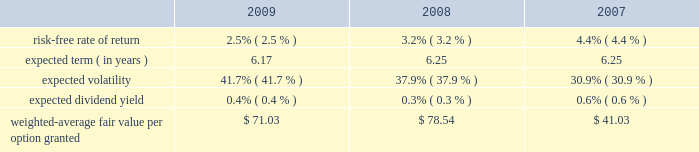Mastercard incorporated notes to consolidated financial statements 2014 ( continued ) ( in thousands , except percent and per share data ) upon termination of employment , excluding retirement , all of a participant 2019s unvested awards are forfeited .
However , when a participant terminates employment due to retirement , the participant generally retains all of their awards without providing additional service to the company .
Eligible retirement is dependent upon age and years of service , as follows : age 55 with ten years of service , age 60 with five years of service and age 65 with two years of service .
Compensation expense is recognized over the shorter of the vesting periods stated in the ltip , or the date the individual becomes eligible to retire .
There are 11550 shares of class a common stock reserved for equity awards under the ltip .
Although the ltip permits the issuance of shares of class b common stock , no such shares have been reserved for issuance .
Shares issued as a result of option exercises and the conversions of rsus are expected to be funded with the issuance of new shares of class a common stock .
Stock options the fair value of each option is estimated on the date of grant using a black-scholes option pricing model .
The table presents the weighted-average assumptions used in the valuation and the resulting weighted- average fair value per option granted for the years ended december 31: .
The risk-free rate of return was based on the u.s .
Treasury yield curve in effect on the date of grant .
The company utilizes the simplified method for calculating the expected term of the option based on the vesting terms and the contractual life of the option .
The expected volatility for options granted during 2009 was based on the average of the implied volatility of mastercard and a blend of the historical volatility of mastercard and the historical volatility of a group of companies that management believes is generally comparable to mastercard .
The expected volatility for options granted during 2008 was based on the average of the implied volatility of mastercard and the historical volatility of a group of companies that management believes is generally comparable to mastercard .
As the company did not have sufficient publicly traded stock data historically , the expected volatility for options granted during 2007 was primarily based on the average of the historical and implied volatility of a group of companies that management believed was generally comparable to mastercard .
The expected dividend yields were based on the company 2019s expected annual dividend rate on the date of grant. .
What is the average expected volatility for the years 2007-2009? 
Rationale: it is the sum of all percentages of expected volatility during this period divided by three .
Computations: table_average(expected volatility, none)
Answer: 0.36833. 